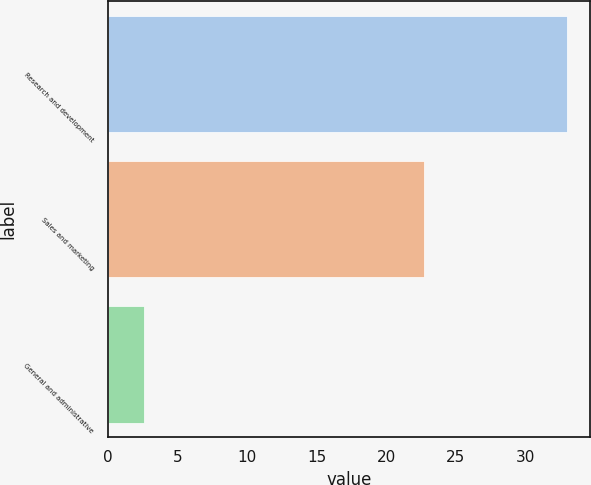Convert chart. <chart><loc_0><loc_0><loc_500><loc_500><bar_chart><fcel>Research and development<fcel>Sales and marketing<fcel>General and administrative<nl><fcel>33<fcel>22.7<fcel>2.6<nl></chart> 